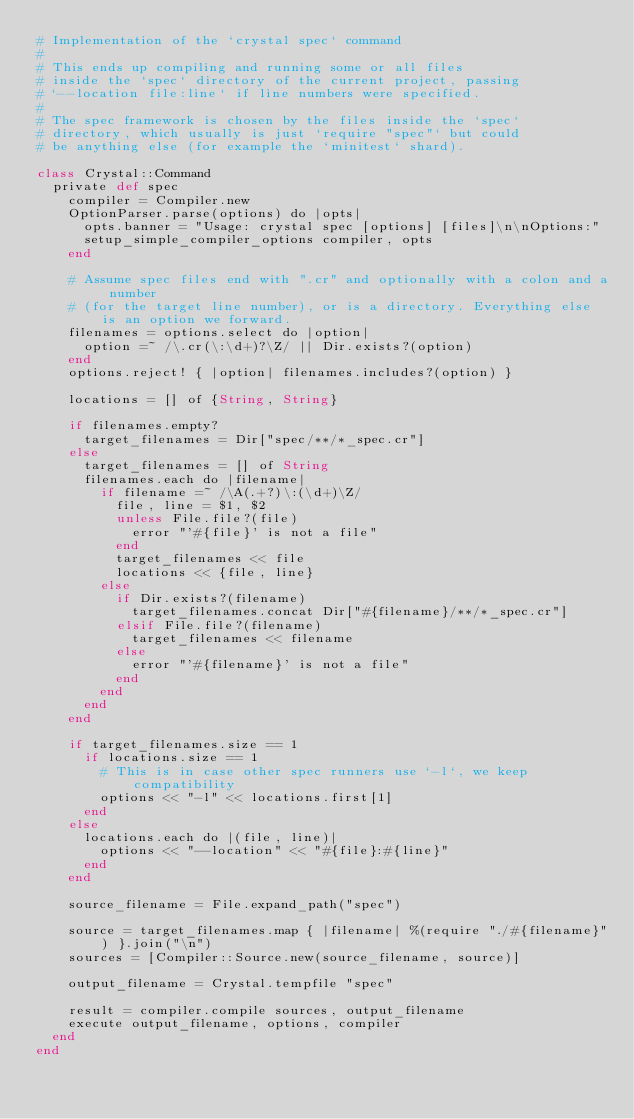Convert code to text. <code><loc_0><loc_0><loc_500><loc_500><_Crystal_># Implementation of the `crystal spec` command
#
# This ends up compiling and running some or all files
# inside the `spec` directory of the current project, passing
# `--location file:line` if line numbers were specified.
#
# The spec framework is chosen by the files inside the `spec`
# directory, which usually is just `require "spec"` but could
# be anything else (for example the `minitest` shard).

class Crystal::Command
  private def spec
    compiler = Compiler.new
    OptionParser.parse(options) do |opts|
      opts.banner = "Usage: crystal spec [options] [files]\n\nOptions:"
      setup_simple_compiler_options compiler, opts
    end

    # Assume spec files end with ".cr" and optionally with a colon and a number
    # (for the target line number), or is a directory. Everything else is an option we forward.
    filenames = options.select do |option|
      option =~ /\.cr(\:\d+)?\Z/ || Dir.exists?(option)
    end
    options.reject! { |option| filenames.includes?(option) }

    locations = [] of {String, String}

    if filenames.empty?
      target_filenames = Dir["spec/**/*_spec.cr"]
    else
      target_filenames = [] of String
      filenames.each do |filename|
        if filename =~ /\A(.+?)\:(\d+)\Z/
          file, line = $1, $2
          unless File.file?(file)
            error "'#{file}' is not a file"
          end
          target_filenames << file
          locations << {file, line}
        else
          if Dir.exists?(filename)
            target_filenames.concat Dir["#{filename}/**/*_spec.cr"]
          elsif File.file?(filename)
            target_filenames << filename
          else
            error "'#{filename}' is not a file"
          end
        end
      end
    end

    if target_filenames.size == 1
      if locations.size == 1
        # This is in case other spec runners use `-l`, we keep compatibility
        options << "-l" << locations.first[1]
      end
    else
      locations.each do |(file, line)|
        options << "--location" << "#{file}:#{line}"
      end
    end

    source_filename = File.expand_path("spec")

    source = target_filenames.map { |filename| %(require "./#{filename}") }.join("\n")
    sources = [Compiler::Source.new(source_filename, source)]

    output_filename = Crystal.tempfile "spec"

    result = compiler.compile sources, output_filename
    execute output_filename, options, compiler
  end
end
</code> 